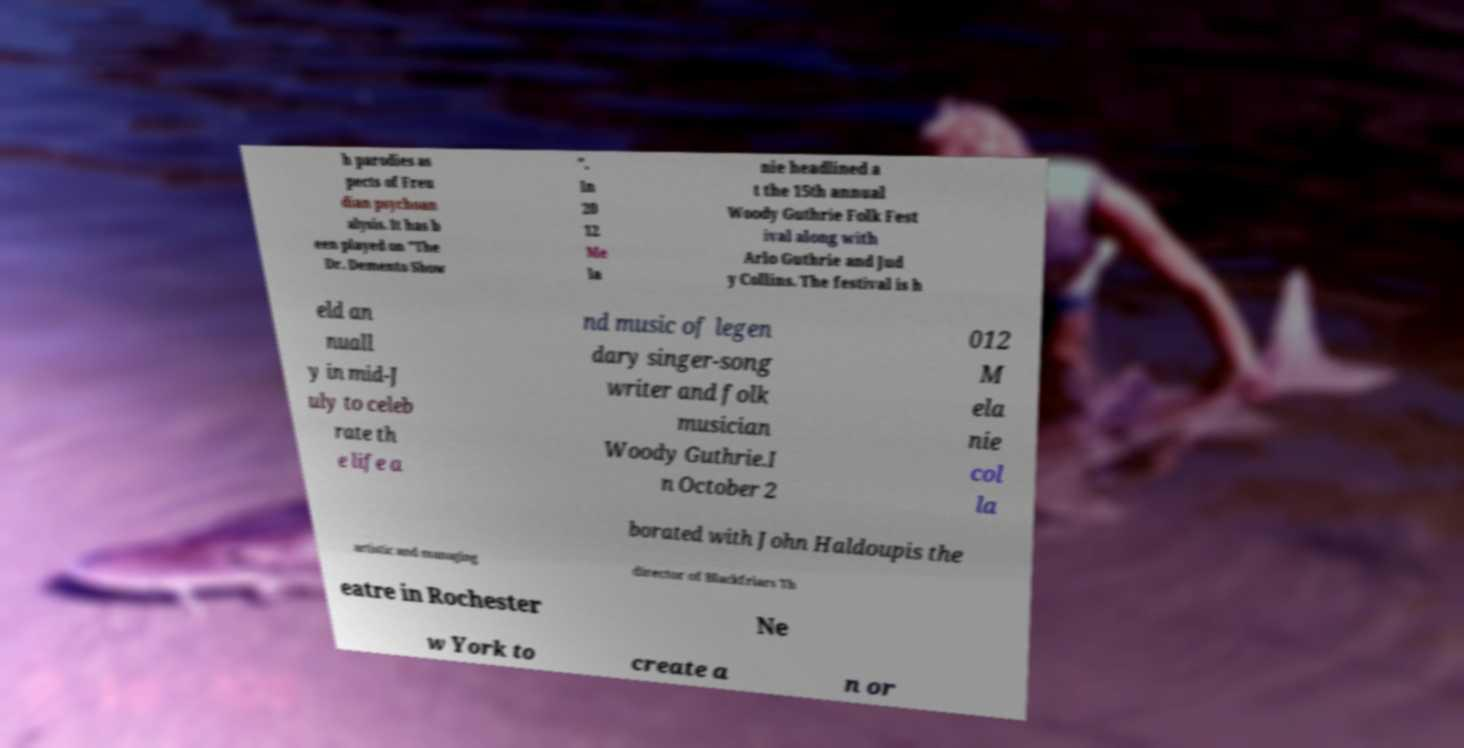Could you extract and type out the text from this image? h parodies as pects of Freu dian psychoan alysis. It has b een played on "The Dr. Demento Show ". In 20 12 Me la nie headlined a t the 15th annual Woody Guthrie Folk Fest ival along with Arlo Guthrie and Jud y Collins. The festival is h eld an nuall y in mid-J uly to celeb rate th e life a nd music of legen dary singer-song writer and folk musician Woody Guthrie.I n October 2 012 M ela nie col la borated with John Haldoupis the artistic and managing director of Blackfriars Th eatre in Rochester Ne w York to create a n or 